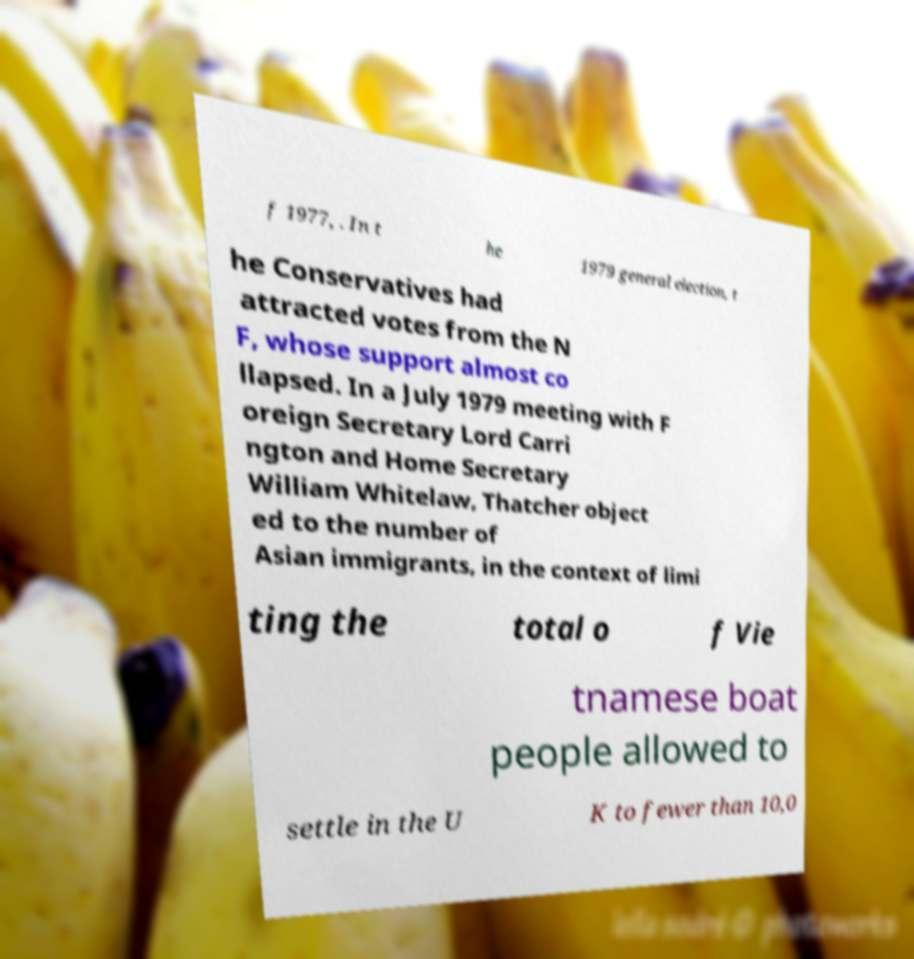I need the written content from this picture converted into text. Can you do that? f 1977, . In t he 1979 general election, t he Conservatives had attracted votes from the N F, whose support almost co llapsed. In a July 1979 meeting with F oreign Secretary Lord Carri ngton and Home Secretary William Whitelaw, Thatcher object ed to the number of Asian immigrants, in the context of limi ting the total o f Vie tnamese boat people allowed to settle in the U K to fewer than 10,0 